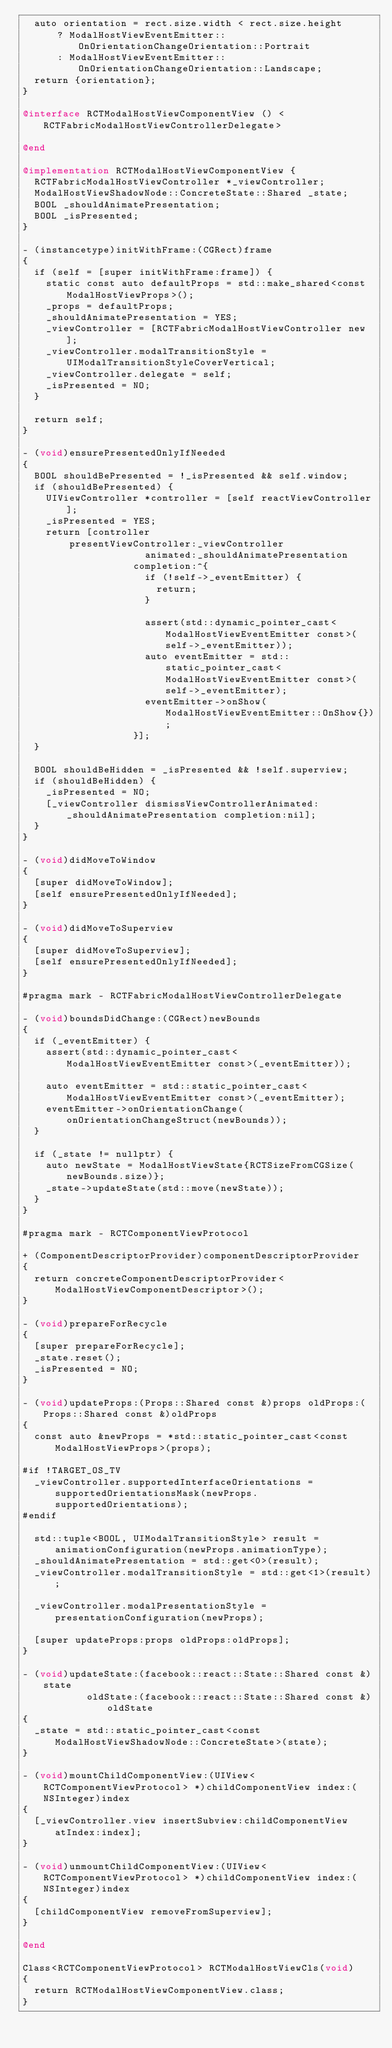<code> <loc_0><loc_0><loc_500><loc_500><_ObjectiveC_>  auto orientation = rect.size.width < rect.size.height
      ? ModalHostViewEventEmitter::OnOrientationChangeOrientation::Portrait
      : ModalHostViewEventEmitter::OnOrientationChangeOrientation::Landscape;
  return {orientation};
}

@interface RCTModalHostViewComponentView () <RCTFabricModalHostViewControllerDelegate>

@end

@implementation RCTModalHostViewComponentView {
  RCTFabricModalHostViewController *_viewController;
  ModalHostViewShadowNode::ConcreteState::Shared _state;
  BOOL _shouldAnimatePresentation;
  BOOL _isPresented;
}

- (instancetype)initWithFrame:(CGRect)frame
{
  if (self = [super initWithFrame:frame]) {
    static const auto defaultProps = std::make_shared<const ModalHostViewProps>();
    _props = defaultProps;
    _shouldAnimatePresentation = YES;
    _viewController = [RCTFabricModalHostViewController new];
    _viewController.modalTransitionStyle = UIModalTransitionStyleCoverVertical;
    _viewController.delegate = self;
    _isPresented = NO;
  }

  return self;
}

- (void)ensurePresentedOnlyIfNeeded
{
  BOOL shouldBePresented = !_isPresented && self.window;
  if (shouldBePresented) {
    UIViewController *controller = [self reactViewController];
    _isPresented = YES;
    return [controller
        presentViewController:_viewController
                     animated:_shouldAnimatePresentation
                   completion:^{
                     if (!self->_eventEmitter) {
                       return;
                     }

                     assert(std::dynamic_pointer_cast<ModalHostViewEventEmitter const>(self->_eventEmitter));
                     auto eventEmitter = std::static_pointer_cast<ModalHostViewEventEmitter const>(self->_eventEmitter);
                     eventEmitter->onShow(ModalHostViewEventEmitter::OnShow{});
                   }];
  }

  BOOL shouldBeHidden = _isPresented && !self.superview;
  if (shouldBeHidden) {
    _isPresented = NO;
    [_viewController dismissViewControllerAnimated:_shouldAnimatePresentation completion:nil];
  }
}

- (void)didMoveToWindow
{
  [super didMoveToWindow];
  [self ensurePresentedOnlyIfNeeded];
}

- (void)didMoveToSuperview
{
  [super didMoveToSuperview];
  [self ensurePresentedOnlyIfNeeded];
}

#pragma mark - RCTFabricModalHostViewControllerDelegate

- (void)boundsDidChange:(CGRect)newBounds
{
  if (_eventEmitter) {
    assert(std::dynamic_pointer_cast<ModalHostViewEventEmitter const>(_eventEmitter));

    auto eventEmitter = std::static_pointer_cast<ModalHostViewEventEmitter const>(_eventEmitter);
    eventEmitter->onOrientationChange(onOrientationChangeStruct(newBounds));
  }

  if (_state != nullptr) {
    auto newState = ModalHostViewState{RCTSizeFromCGSize(newBounds.size)};
    _state->updateState(std::move(newState));
  }
}

#pragma mark - RCTComponentViewProtocol

+ (ComponentDescriptorProvider)componentDescriptorProvider
{
  return concreteComponentDescriptorProvider<ModalHostViewComponentDescriptor>();
}

- (void)prepareForRecycle
{
  [super prepareForRecycle];
  _state.reset();
  _isPresented = NO;
}

- (void)updateProps:(Props::Shared const &)props oldProps:(Props::Shared const &)oldProps
{
  const auto &newProps = *std::static_pointer_cast<const ModalHostViewProps>(props);

#if !TARGET_OS_TV
  _viewController.supportedInterfaceOrientations = supportedOrientationsMask(newProps.supportedOrientations);
#endif

  std::tuple<BOOL, UIModalTransitionStyle> result = animationConfiguration(newProps.animationType);
  _shouldAnimatePresentation = std::get<0>(result);
  _viewController.modalTransitionStyle = std::get<1>(result);

  _viewController.modalPresentationStyle = presentationConfiguration(newProps);

  [super updateProps:props oldProps:oldProps];
}

- (void)updateState:(facebook::react::State::Shared const &)state
           oldState:(facebook::react::State::Shared const &)oldState
{
  _state = std::static_pointer_cast<const ModalHostViewShadowNode::ConcreteState>(state);
}

- (void)mountChildComponentView:(UIView<RCTComponentViewProtocol> *)childComponentView index:(NSInteger)index
{
  [_viewController.view insertSubview:childComponentView atIndex:index];
}

- (void)unmountChildComponentView:(UIView<RCTComponentViewProtocol> *)childComponentView index:(NSInteger)index
{
  [childComponentView removeFromSuperview];
}

@end

Class<RCTComponentViewProtocol> RCTModalHostViewCls(void)
{
  return RCTModalHostViewComponentView.class;
}
</code> 